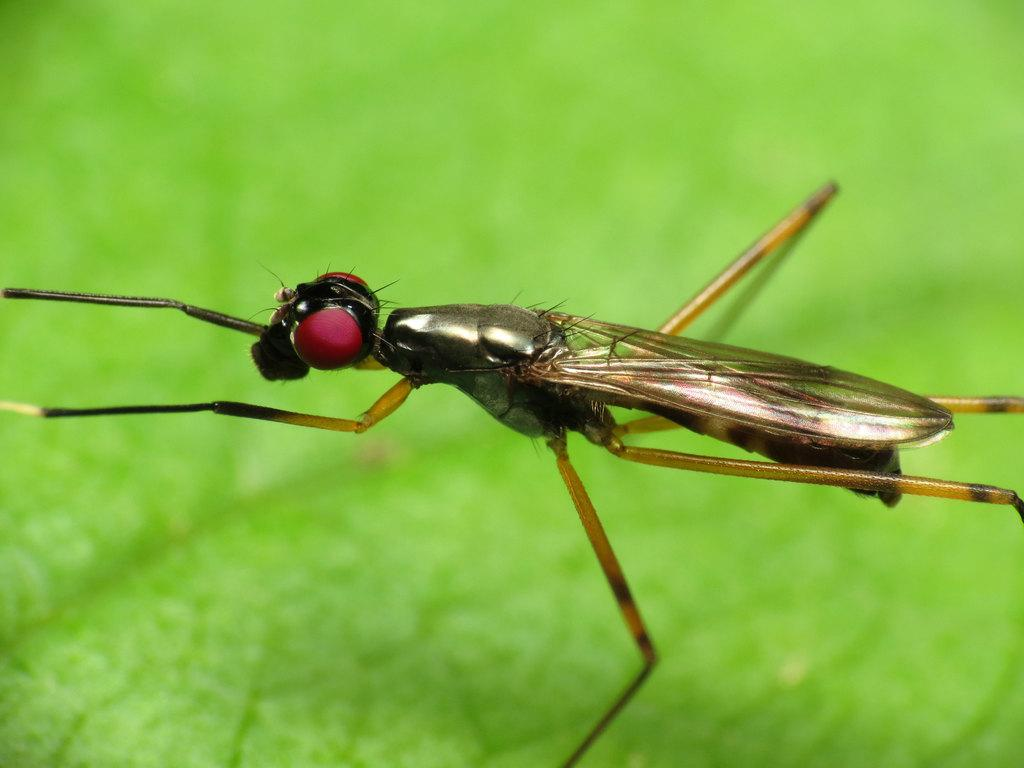What type of creature can be seen in the image? There is an insect in the image. Where is the insect located in the image? The insect is on a surface. What type of plant can be seen growing in the cellar of the town in the image? There is no plant, cellar, or town present in the image; it only features an insect on a surface. 